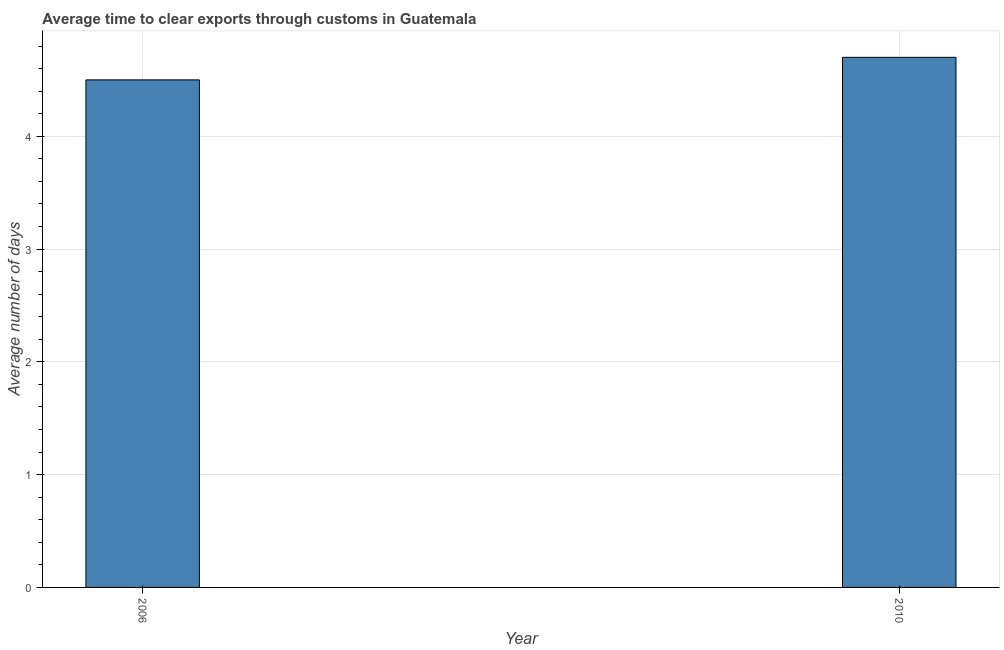Does the graph contain any zero values?
Provide a succinct answer. No. Does the graph contain grids?
Ensure brevity in your answer.  Yes. What is the title of the graph?
Ensure brevity in your answer.  Average time to clear exports through customs in Guatemala. What is the label or title of the Y-axis?
Keep it short and to the point. Average number of days. In which year was the time to clear exports through customs maximum?
Offer a terse response. 2010. In which year was the time to clear exports through customs minimum?
Your answer should be compact. 2006. What is the sum of the time to clear exports through customs?
Keep it short and to the point. 9.2. What is the difference between the time to clear exports through customs in 2006 and 2010?
Your answer should be compact. -0.2. What is the average time to clear exports through customs per year?
Keep it short and to the point. 4.6. In how many years, is the time to clear exports through customs greater than 1.4 days?
Keep it short and to the point. 2. Do a majority of the years between 2006 and 2010 (inclusive) have time to clear exports through customs greater than 0.8 days?
Offer a terse response. Yes. Is the time to clear exports through customs in 2006 less than that in 2010?
Offer a terse response. Yes. How many bars are there?
Give a very brief answer. 2. Are the values on the major ticks of Y-axis written in scientific E-notation?
Your response must be concise. No. What is the ratio of the Average number of days in 2006 to that in 2010?
Provide a succinct answer. 0.96. 